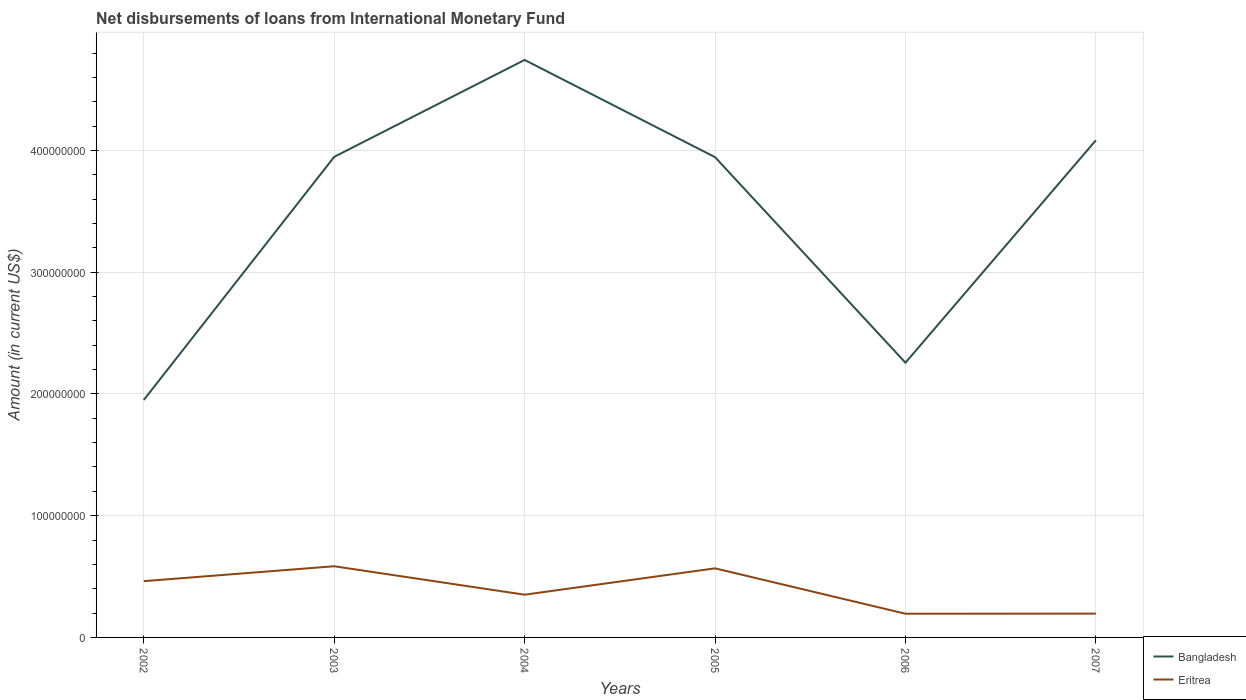How many different coloured lines are there?
Ensure brevity in your answer.  2. Does the line corresponding to Bangladesh intersect with the line corresponding to Eritrea?
Ensure brevity in your answer.  No. Is the number of lines equal to the number of legend labels?
Offer a terse response. Yes. Across all years, what is the maximum amount of loans disbursed in Bangladesh?
Give a very brief answer. 1.95e+08. What is the total amount of loans disbursed in Eritrea in the graph?
Provide a short and direct response. 1.72e+06. What is the difference between the highest and the second highest amount of loans disbursed in Bangladesh?
Provide a short and direct response. 2.79e+08. How many lines are there?
Offer a terse response. 2. How many years are there in the graph?
Ensure brevity in your answer.  6. How many legend labels are there?
Your answer should be very brief. 2. How are the legend labels stacked?
Your response must be concise. Vertical. What is the title of the graph?
Your answer should be compact. Net disbursements of loans from International Monetary Fund. Does "Iceland" appear as one of the legend labels in the graph?
Provide a short and direct response. No. What is the label or title of the Y-axis?
Your answer should be compact. Amount (in current US$). What is the Amount (in current US$) of Bangladesh in 2002?
Ensure brevity in your answer.  1.95e+08. What is the Amount (in current US$) of Eritrea in 2002?
Ensure brevity in your answer.  4.62e+07. What is the Amount (in current US$) of Bangladesh in 2003?
Make the answer very short. 3.95e+08. What is the Amount (in current US$) of Eritrea in 2003?
Keep it short and to the point. 5.85e+07. What is the Amount (in current US$) in Bangladesh in 2004?
Offer a terse response. 4.74e+08. What is the Amount (in current US$) of Eritrea in 2004?
Provide a succinct answer. 3.51e+07. What is the Amount (in current US$) in Bangladesh in 2005?
Offer a terse response. 3.94e+08. What is the Amount (in current US$) in Eritrea in 2005?
Provide a succinct answer. 5.67e+07. What is the Amount (in current US$) in Bangladesh in 2006?
Provide a short and direct response. 2.26e+08. What is the Amount (in current US$) in Eritrea in 2006?
Ensure brevity in your answer.  1.95e+07. What is the Amount (in current US$) of Bangladesh in 2007?
Ensure brevity in your answer.  4.08e+08. What is the Amount (in current US$) of Eritrea in 2007?
Your response must be concise. 1.96e+07. Across all years, what is the maximum Amount (in current US$) of Bangladesh?
Your answer should be very brief. 4.74e+08. Across all years, what is the maximum Amount (in current US$) in Eritrea?
Your answer should be compact. 5.85e+07. Across all years, what is the minimum Amount (in current US$) in Bangladesh?
Provide a succinct answer. 1.95e+08. Across all years, what is the minimum Amount (in current US$) in Eritrea?
Your answer should be compact. 1.95e+07. What is the total Amount (in current US$) in Bangladesh in the graph?
Your answer should be compact. 2.09e+09. What is the total Amount (in current US$) in Eritrea in the graph?
Give a very brief answer. 2.36e+08. What is the difference between the Amount (in current US$) of Bangladesh in 2002 and that in 2003?
Offer a very short reply. -2.00e+08. What is the difference between the Amount (in current US$) of Eritrea in 2002 and that in 2003?
Keep it short and to the point. -1.22e+07. What is the difference between the Amount (in current US$) in Bangladesh in 2002 and that in 2004?
Ensure brevity in your answer.  -2.79e+08. What is the difference between the Amount (in current US$) of Eritrea in 2002 and that in 2004?
Keep it short and to the point. 1.11e+07. What is the difference between the Amount (in current US$) in Bangladesh in 2002 and that in 2005?
Your answer should be very brief. -1.99e+08. What is the difference between the Amount (in current US$) in Eritrea in 2002 and that in 2005?
Offer a terse response. -1.05e+07. What is the difference between the Amount (in current US$) in Bangladesh in 2002 and that in 2006?
Offer a terse response. -3.06e+07. What is the difference between the Amount (in current US$) in Eritrea in 2002 and that in 2006?
Offer a terse response. 2.67e+07. What is the difference between the Amount (in current US$) of Bangladesh in 2002 and that in 2007?
Your answer should be very brief. -2.13e+08. What is the difference between the Amount (in current US$) in Eritrea in 2002 and that in 2007?
Offer a very short reply. 2.67e+07. What is the difference between the Amount (in current US$) of Bangladesh in 2003 and that in 2004?
Provide a succinct answer. -7.96e+07. What is the difference between the Amount (in current US$) in Eritrea in 2003 and that in 2004?
Your response must be concise. 2.34e+07. What is the difference between the Amount (in current US$) of Bangladesh in 2003 and that in 2005?
Your answer should be very brief. 2.41e+05. What is the difference between the Amount (in current US$) of Eritrea in 2003 and that in 2005?
Make the answer very short. 1.72e+06. What is the difference between the Amount (in current US$) of Bangladesh in 2003 and that in 2006?
Your answer should be compact. 1.69e+08. What is the difference between the Amount (in current US$) in Eritrea in 2003 and that in 2006?
Provide a short and direct response. 3.90e+07. What is the difference between the Amount (in current US$) in Bangladesh in 2003 and that in 2007?
Your response must be concise. -1.36e+07. What is the difference between the Amount (in current US$) of Eritrea in 2003 and that in 2007?
Provide a short and direct response. 3.89e+07. What is the difference between the Amount (in current US$) of Bangladesh in 2004 and that in 2005?
Offer a very short reply. 7.98e+07. What is the difference between the Amount (in current US$) in Eritrea in 2004 and that in 2005?
Offer a very short reply. -2.16e+07. What is the difference between the Amount (in current US$) of Bangladesh in 2004 and that in 2006?
Offer a terse response. 2.49e+08. What is the difference between the Amount (in current US$) of Eritrea in 2004 and that in 2006?
Make the answer very short. 1.56e+07. What is the difference between the Amount (in current US$) of Bangladesh in 2004 and that in 2007?
Offer a very short reply. 6.60e+07. What is the difference between the Amount (in current US$) in Eritrea in 2004 and that in 2007?
Keep it short and to the point. 1.55e+07. What is the difference between the Amount (in current US$) in Bangladesh in 2005 and that in 2006?
Provide a short and direct response. 1.69e+08. What is the difference between the Amount (in current US$) in Eritrea in 2005 and that in 2006?
Your answer should be very brief. 3.73e+07. What is the difference between the Amount (in current US$) in Bangladesh in 2005 and that in 2007?
Your answer should be compact. -1.38e+07. What is the difference between the Amount (in current US$) of Eritrea in 2005 and that in 2007?
Make the answer very short. 3.72e+07. What is the difference between the Amount (in current US$) of Bangladesh in 2006 and that in 2007?
Your answer should be compact. -1.83e+08. What is the difference between the Amount (in current US$) of Eritrea in 2006 and that in 2007?
Your answer should be very brief. -8.30e+04. What is the difference between the Amount (in current US$) in Bangladesh in 2002 and the Amount (in current US$) in Eritrea in 2003?
Provide a succinct answer. 1.37e+08. What is the difference between the Amount (in current US$) of Bangladesh in 2002 and the Amount (in current US$) of Eritrea in 2004?
Ensure brevity in your answer.  1.60e+08. What is the difference between the Amount (in current US$) of Bangladesh in 2002 and the Amount (in current US$) of Eritrea in 2005?
Your answer should be compact. 1.38e+08. What is the difference between the Amount (in current US$) of Bangladesh in 2002 and the Amount (in current US$) of Eritrea in 2006?
Make the answer very short. 1.76e+08. What is the difference between the Amount (in current US$) of Bangladesh in 2002 and the Amount (in current US$) of Eritrea in 2007?
Offer a terse response. 1.75e+08. What is the difference between the Amount (in current US$) of Bangladesh in 2003 and the Amount (in current US$) of Eritrea in 2004?
Provide a succinct answer. 3.60e+08. What is the difference between the Amount (in current US$) of Bangladesh in 2003 and the Amount (in current US$) of Eritrea in 2005?
Your answer should be compact. 3.38e+08. What is the difference between the Amount (in current US$) in Bangladesh in 2003 and the Amount (in current US$) in Eritrea in 2006?
Your answer should be very brief. 3.75e+08. What is the difference between the Amount (in current US$) of Bangladesh in 2003 and the Amount (in current US$) of Eritrea in 2007?
Your answer should be compact. 3.75e+08. What is the difference between the Amount (in current US$) in Bangladesh in 2004 and the Amount (in current US$) in Eritrea in 2005?
Provide a succinct answer. 4.18e+08. What is the difference between the Amount (in current US$) in Bangladesh in 2004 and the Amount (in current US$) in Eritrea in 2006?
Offer a very short reply. 4.55e+08. What is the difference between the Amount (in current US$) of Bangladesh in 2004 and the Amount (in current US$) of Eritrea in 2007?
Give a very brief answer. 4.55e+08. What is the difference between the Amount (in current US$) in Bangladesh in 2005 and the Amount (in current US$) in Eritrea in 2006?
Ensure brevity in your answer.  3.75e+08. What is the difference between the Amount (in current US$) of Bangladesh in 2005 and the Amount (in current US$) of Eritrea in 2007?
Your response must be concise. 3.75e+08. What is the difference between the Amount (in current US$) in Bangladesh in 2006 and the Amount (in current US$) in Eritrea in 2007?
Provide a succinct answer. 2.06e+08. What is the average Amount (in current US$) of Bangladesh per year?
Your answer should be very brief. 3.49e+08. What is the average Amount (in current US$) of Eritrea per year?
Make the answer very short. 3.93e+07. In the year 2002, what is the difference between the Amount (in current US$) in Bangladesh and Amount (in current US$) in Eritrea?
Offer a terse response. 1.49e+08. In the year 2003, what is the difference between the Amount (in current US$) of Bangladesh and Amount (in current US$) of Eritrea?
Your answer should be compact. 3.36e+08. In the year 2004, what is the difference between the Amount (in current US$) in Bangladesh and Amount (in current US$) in Eritrea?
Provide a short and direct response. 4.39e+08. In the year 2005, what is the difference between the Amount (in current US$) of Bangladesh and Amount (in current US$) of Eritrea?
Your answer should be very brief. 3.38e+08. In the year 2006, what is the difference between the Amount (in current US$) of Bangladesh and Amount (in current US$) of Eritrea?
Provide a succinct answer. 2.06e+08. In the year 2007, what is the difference between the Amount (in current US$) of Bangladesh and Amount (in current US$) of Eritrea?
Your answer should be very brief. 3.89e+08. What is the ratio of the Amount (in current US$) of Bangladesh in 2002 to that in 2003?
Keep it short and to the point. 0.49. What is the ratio of the Amount (in current US$) of Eritrea in 2002 to that in 2003?
Your answer should be very brief. 0.79. What is the ratio of the Amount (in current US$) of Bangladesh in 2002 to that in 2004?
Your answer should be compact. 0.41. What is the ratio of the Amount (in current US$) in Eritrea in 2002 to that in 2004?
Provide a succinct answer. 1.32. What is the ratio of the Amount (in current US$) of Bangladesh in 2002 to that in 2005?
Provide a succinct answer. 0.49. What is the ratio of the Amount (in current US$) of Eritrea in 2002 to that in 2005?
Your answer should be very brief. 0.81. What is the ratio of the Amount (in current US$) of Bangladesh in 2002 to that in 2006?
Keep it short and to the point. 0.86. What is the ratio of the Amount (in current US$) of Eritrea in 2002 to that in 2006?
Provide a succinct answer. 2.37. What is the ratio of the Amount (in current US$) of Bangladesh in 2002 to that in 2007?
Make the answer very short. 0.48. What is the ratio of the Amount (in current US$) in Eritrea in 2002 to that in 2007?
Make the answer very short. 2.36. What is the ratio of the Amount (in current US$) in Bangladesh in 2003 to that in 2004?
Keep it short and to the point. 0.83. What is the ratio of the Amount (in current US$) in Eritrea in 2003 to that in 2004?
Make the answer very short. 1.67. What is the ratio of the Amount (in current US$) of Eritrea in 2003 to that in 2005?
Ensure brevity in your answer.  1.03. What is the ratio of the Amount (in current US$) of Bangladesh in 2003 to that in 2006?
Offer a very short reply. 1.75. What is the ratio of the Amount (in current US$) in Eritrea in 2003 to that in 2006?
Your response must be concise. 3. What is the ratio of the Amount (in current US$) of Bangladesh in 2003 to that in 2007?
Give a very brief answer. 0.97. What is the ratio of the Amount (in current US$) of Eritrea in 2003 to that in 2007?
Your response must be concise. 2.99. What is the ratio of the Amount (in current US$) of Bangladesh in 2004 to that in 2005?
Provide a succinct answer. 1.2. What is the ratio of the Amount (in current US$) in Eritrea in 2004 to that in 2005?
Provide a short and direct response. 0.62. What is the ratio of the Amount (in current US$) in Bangladesh in 2004 to that in 2006?
Your response must be concise. 2.1. What is the ratio of the Amount (in current US$) in Eritrea in 2004 to that in 2006?
Provide a succinct answer. 1.8. What is the ratio of the Amount (in current US$) of Bangladesh in 2004 to that in 2007?
Your answer should be very brief. 1.16. What is the ratio of the Amount (in current US$) in Eritrea in 2004 to that in 2007?
Provide a short and direct response. 1.79. What is the ratio of the Amount (in current US$) of Bangladesh in 2005 to that in 2006?
Your answer should be very brief. 1.75. What is the ratio of the Amount (in current US$) of Eritrea in 2005 to that in 2006?
Your answer should be very brief. 2.91. What is the ratio of the Amount (in current US$) of Bangladesh in 2005 to that in 2007?
Provide a short and direct response. 0.97. What is the ratio of the Amount (in current US$) of Eritrea in 2005 to that in 2007?
Provide a succinct answer. 2.9. What is the ratio of the Amount (in current US$) of Bangladesh in 2006 to that in 2007?
Your answer should be very brief. 0.55. What is the ratio of the Amount (in current US$) in Eritrea in 2006 to that in 2007?
Your response must be concise. 1. What is the difference between the highest and the second highest Amount (in current US$) of Bangladesh?
Provide a short and direct response. 6.60e+07. What is the difference between the highest and the second highest Amount (in current US$) in Eritrea?
Provide a succinct answer. 1.72e+06. What is the difference between the highest and the lowest Amount (in current US$) in Bangladesh?
Your answer should be very brief. 2.79e+08. What is the difference between the highest and the lowest Amount (in current US$) of Eritrea?
Your answer should be very brief. 3.90e+07. 